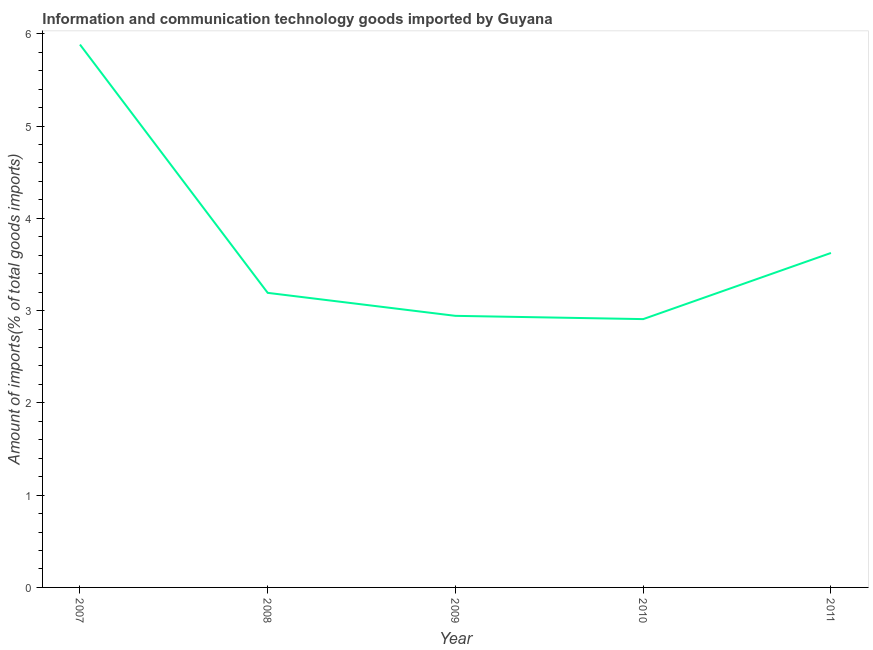What is the amount of ict goods imports in 2010?
Make the answer very short. 2.91. Across all years, what is the maximum amount of ict goods imports?
Offer a very short reply. 5.88. Across all years, what is the minimum amount of ict goods imports?
Provide a succinct answer. 2.91. What is the sum of the amount of ict goods imports?
Offer a terse response. 18.55. What is the difference between the amount of ict goods imports in 2008 and 2011?
Make the answer very short. -0.43. What is the average amount of ict goods imports per year?
Offer a terse response. 3.71. What is the median amount of ict goods imports?
Offer a very short reply. 3.19. In how many years, is the amount of ict goods imports greater than 0.6000000000000001 %?
Provide a succinct answer. 5. What is the ratio of the amount of ict goods imports in 2007 to that in 2011?
Your answer should be very brief. 1.62. Is the amount of ict goods imports in 2007 less than that in 2009?
Your answer should be very brief. No. What is the difference between the highest and the second highest amount of ict goods imports?
Offer a very short reply. 2.26. What is the difference between the highest and the lowest amount of ict goods imports?
Keep it short and to the point. 2.98. How many lines are there?
Make the answer very short. 1. How many years are there in the graph?
Your response must be concise. 5. Does the graph contain any zero values?
Make the answer very short. No. Does the graph contain grids?
Ensure brevity in your answer.  No. What is the title of the graph?
Your answer should be very brief. Information and communication technology goods imported by Guyana. What is the label or title of the Y-axis?
Offer a terse response. Amount of imports(% of total goods imports). What is the Amount of imports(% of total goods imports) of 2007?
Keep it short and to the point. 5.88. What is the Amount of imports(% of total goods imports) of 2008?
Provide a short and direct response. 3.19. What is the Amount of imports(% of total goods imports) in 2009?
Keep it short and to the point. 2.94. What is the Amount of imports(% of total goods imports) in 2010?
Give a very brief answer. 2.91. What is the Amount of imports(% of total goods imports) in 2011?
Your answer should be very brief. 3.62. What is the difference between the Amount of imports(% of total goods imports) in 2007 and 2008?
Your response must be concise. 2.69. What is the difference between the Amount of imports(% of total goods imports) in 2007 and 2009?
Your answer should be very brief. 2.94. What is the difference between the Amount of imports(% of total goods imports) in 2007 and 2010?
Provide a short and direct response. 2.98. What is the difference between the Amount of imports(% of total goods imports) in 2007 and 2011?
Your answer should be compact. 2.26. What is the difference between the Amount of imports(% of total goods imports) in 2008 and 2009?
Ensure brevity in your answer.  0.25. What is the difference between the Amount of imports(% of total goods imports) in 2008 and 2010?
Your answer should be compact. 0.28. What is the difference between the Amount of imports(% of total goods imports) in 2008 and 2011?
Offer a very short reply. -0.43. What is the difference between the Amount of imports(% of total goods imports) in 2009 and 2010?
Give a very brief answer. 0.04. What is the difference between the Amount of imports(% of total goods imports) in 2009 and 2011?
Your answer should be compact. -0.68. What is the difference between the Amount of imports(% of total goods imports) in 2010 and 2011?
Your answer should be compact. -0.72. What is the ratio of the Amount of imports(% of total goods imports) in 2007 to that in 2008?
Make the answer very short. 1.84. What is the ratio of the Amount of imports(% of total goods imports) in 2007 to that in 2009?
Provide a short and direct response. 2. What is the ratio of the Amount of imports(% of total goods imports) in 2007 to that in 2010?
Provide a short and direct response. 2.02. What is the ratio of the Amount of imports(% of total goods imports) in 2007 to that in 2011?
Your response must be concise. 1.62. What is the ratio of the Amount of imports(% of total goods imports) in 2008 to that in 2009?
Offer a terse response. 1.08. What is the ratio of the Amount of imports(% of total goods imports) in 2008 to that in 2010?
Your response must be concise. 1.1. What is the ratio of the Amount of imports(% of total goods imports) in 2008 to that in 2011?
Provide a succinct answer. 0.88. What is the ratio of the Amount of imports(% of total goods imports) in 2009 to that in 2011?
Give a very brief answer. 0.81. What is the ratio of the Amount of imports(% of total goods imports) in 2010 to that in 2011?
Offer a very short reply. 0.8. 